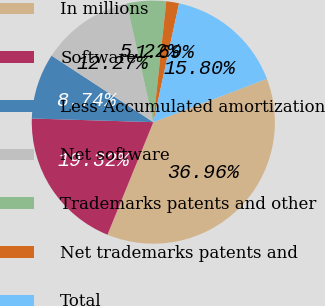Convert chart. <chart><loc_0><loc_0><loc_500><loc_500><pie_chart><fcel>In millions<fcel>Software<fcel>Less Accumulated amortization<fcel>Net software<fcel>Trademarks patents and other<fcel>Net trademarks patents and<fcel>Total<nl><fcel>36.96%<fcel>19.32%<fcel>8.74%<fcel>12.27%<fcel>5.22%<fcel>1.69%<fcel>15.8%<nl></chart> 